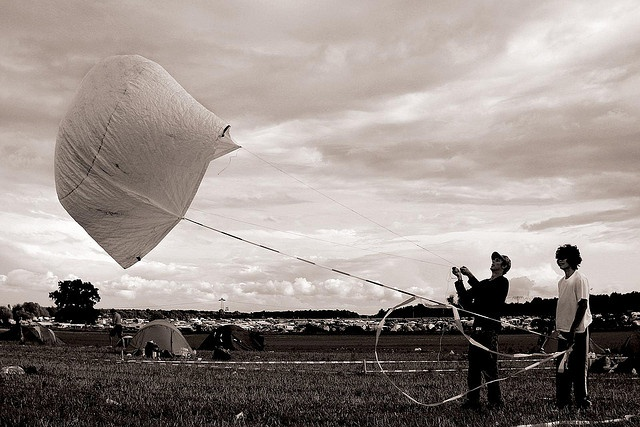Describe the objects in this image and their specific colors. I can see kite in darkgray and gray tones, people in darkgray, black, gray, and lightgray tones, people in darkgray, black, gray, and lightgray tones, people in darkgray, black, and gray tones, and people in darkgray, black, and gray tones in this image. 